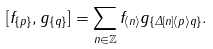Convert formula to latex. <formula><loc_0><loc_0><loc_500><loc_500>[ f _ { \{ p \} } , g _ { \{ q \} } ] = \sum _ { n \in \mathbb { Z } } f _ { \langle n \rangle } g _ { \{ \Delta [ n ] \langle p \rangle q \} } .</formula> 